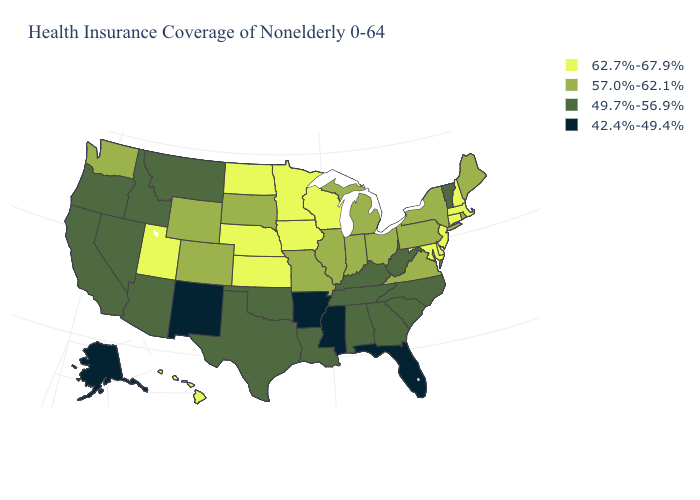What is the value of Nevada?
Be succinct. 49.7%-56.9%. What is the value of Arkansas?
Keep it brief. 42.4%-49.4%. Among the states that border Mississippi , which have the lowest value?
Write a very short answer. Arkansas. Among the states that border Connecticut , which have the highest value?
Give a very brief answer. Massachusetts. Name the states that have a value in the range 49.7%-56.9%?
Short answer required. Alabama, Arizona, California, Georgia, Idaho, Kentucky, Louisiana, Montana, Nevada, North Carolina, Oklahoma, Oregon, South Carolina, Tennessee, Texas, Vermont, West Virginia. Is the legend a continuous bar?
Short answer required. No. Name the states that have a value in the range 42.4%-49.4%?
Keep it brief. Alaska, Arkansas, Florida, Mississippi, New Mexico. What is the lowest value in states that border Washington?
Give a very brief answer. 49.7%-56.9%. Does Delaware have the highest value in the South?
Short answer required. Yes. What is the highest value in the USA?
Give a very brief answer. 62.7%-67.9%. Does New Jersey have a higher value than Louisiana?
Concise answer only. Yes. Name the states that have a value in the range 42.4%-49.4%?
Keep it brief. Alaska, Arkansas, Florida, Mississippi, New Mexico. What is the highest value in the MidWest ?
Keep it brief. 62.7%-67.9%. 